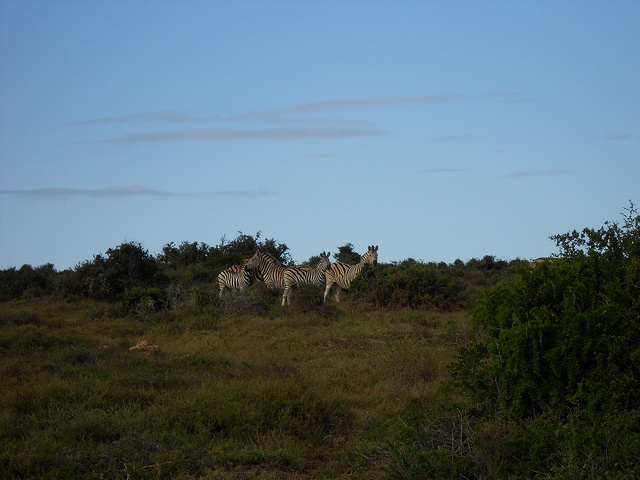Describe the objects in this image and their specific colors. I can see zebra in gray and black tones, zebra in gray and black tones, zebra in gray and black tones, zebra in gray and black tones, and zebra in gray and black tones in this image. 